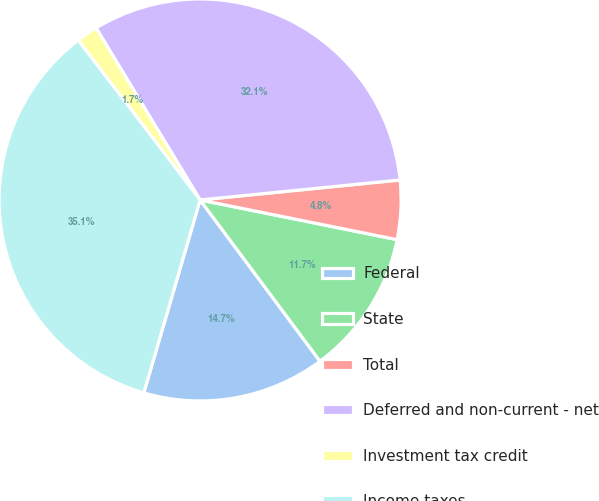<chart> <loc_0><loc_0><loc_500><loc_500><pie_chart><fcel>Federal<fcel>State<fcel>Total<fcel>Deferred and non-current - net<fcel>Investment tax credit<fcel>Income taxes<nl><fcel>14.69%<fcel>11.66%<fcel>4.75%<fcel>32.07%<fcel>1.71%<fcel>35.11%<nl></chart> 